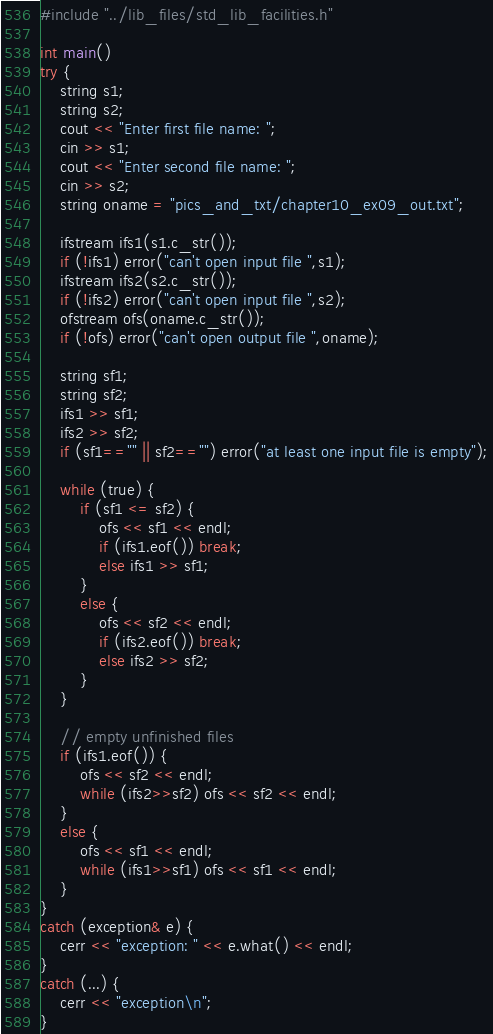Convert code to text. <code><loc_0><loc_0><loc_500><loc_500><_C++_>#include "../lib_files/std_lib_facilities.h"

int main()
try {
    string s1;
    string s2;
    cout << "Enter first file name: ";
    cin >> s1;
    cout << "Enter second file name: ";
    cin >> s2;
    string oname = "pics_and_txt/chapter10_ex09_out.txt";

    ifstream ifs1(s1.c_str());
    if (!ifs1) error("can't open input file ",s1);
    ifstream ifs2(s2.c_str());
    if (!ifs2) error("can't open input file ",s2);
    ofstream ofs(oname.c_str());
    if (!ofs) error("can't open output file ",oname);

    string sf1;
    string sf2;
    ifs1 >> sf1;
    ifs2 >> sf2;
    if (sf1=="" || sf2=="") error("at least one input file is empty");

    while (true) {
        if (sf1 <= sf2) {
            ofs << sf1 << endl;
            if (ifs1.eof()) break;
            else ifs1 >> sf1;
        }
        else {
            ofs << sf2 << endl;
            if (ifs2.eof()) break;
            else ifs2 >> sf2;
        }
    }

    // empty unfinished files
    if (ifs1.eof()) {
        ofs << sf2 << endl;
        while (ifs2>>sf2) ofs << sf2 << endl;
    }
    else {
        ofs << sf1 << endl;
        while (ifs1>>sf1) ofs << sf1 << endl;
    }
}
catch (exception& e) {
    cerr << "exception: " << e.what() << endl;
}
catch (...) {
    cerr << "exception\n";
}
</code> 